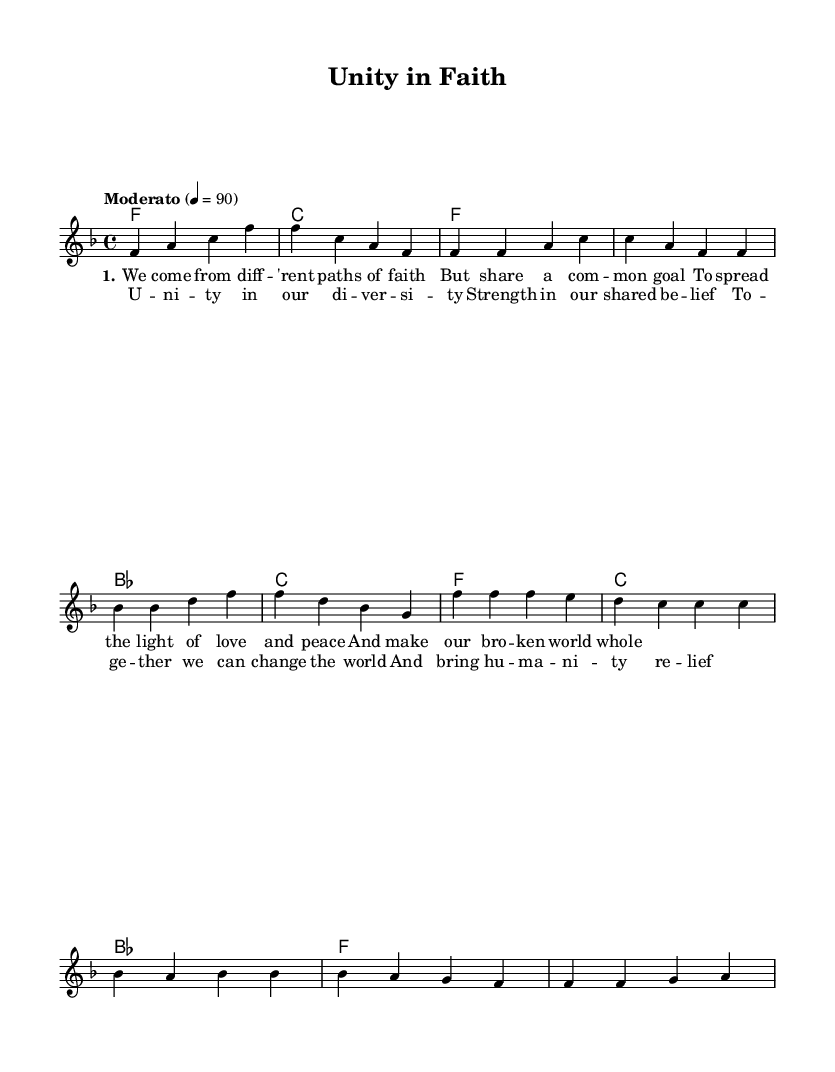What is the key signature of this music? The key signature is F major, which has one flat (B flat). It can be identified by looking at the key signature notation at the beginning of the staff.
Answer: F major What is the time signature of this music? The time signature is 4/4, which indicates four beats in a measure and a quarter note gets one beat. This can be seen at the beginning of the score indicated by the "4/4" symbol.
Answer: 4/4 What is the tempo marking for this piece? The tempo marking is "Moderato," which indicates a moderate pace. This is stated at the beginning of the music under the tempo indication.
Answer: Moderato How many measures are in the chorus section? The chorus section consists of 4 measures. This can be determined by counting the measure lines in the part of the score labeled as the chorus.
Answer: 4 What is the repeated musical phrase in the chorus? The repeated phrase in the chorus is "U -- ni -- ty in our di -- ver -- si -- ty." This is notable as it appears twice in the lyrics of the chorus and emphasizes the theme of unity.
Answer: U -- ni -- ty in our di -- ver -- si -- ty How many chords are used in the intro section? The intro section uses 2 chords: F and C. This can be confirmed by looking at the chord names above the measures in the intro segment of the score.
Answer: 2 